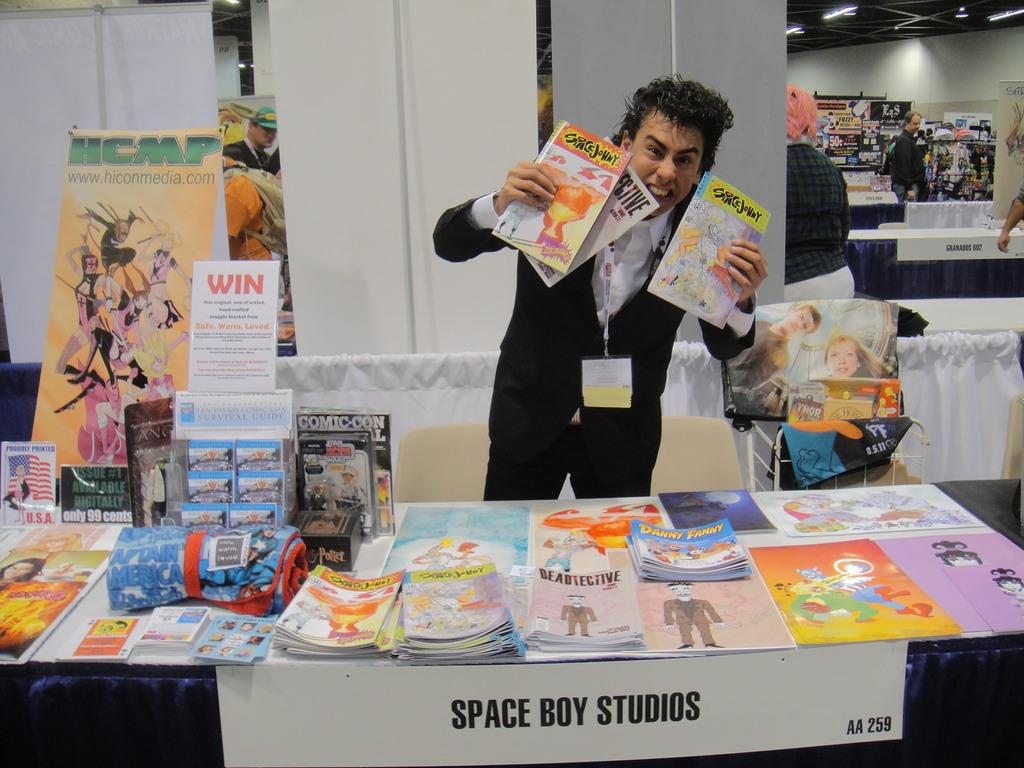Provide a one-sentence caption for the provided image. Man holding multiple Space Johny books at a fair. 